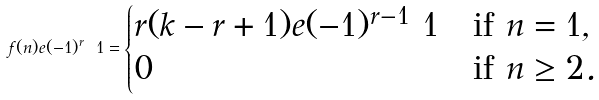Convert formula to latex. <formula><loc_0><loc_0><loc_500><loc_500>f ( n ) e ( - 1 ) ^ { r } \ 1 = \begin{cases} r ( k - r + 1 ) e ( - 1 ) ^ { r - 1 } \ 1 & \text {if $n=1$} , \\ 0 & \text {if $n \geq 2$} . \end{cases}</formula> 